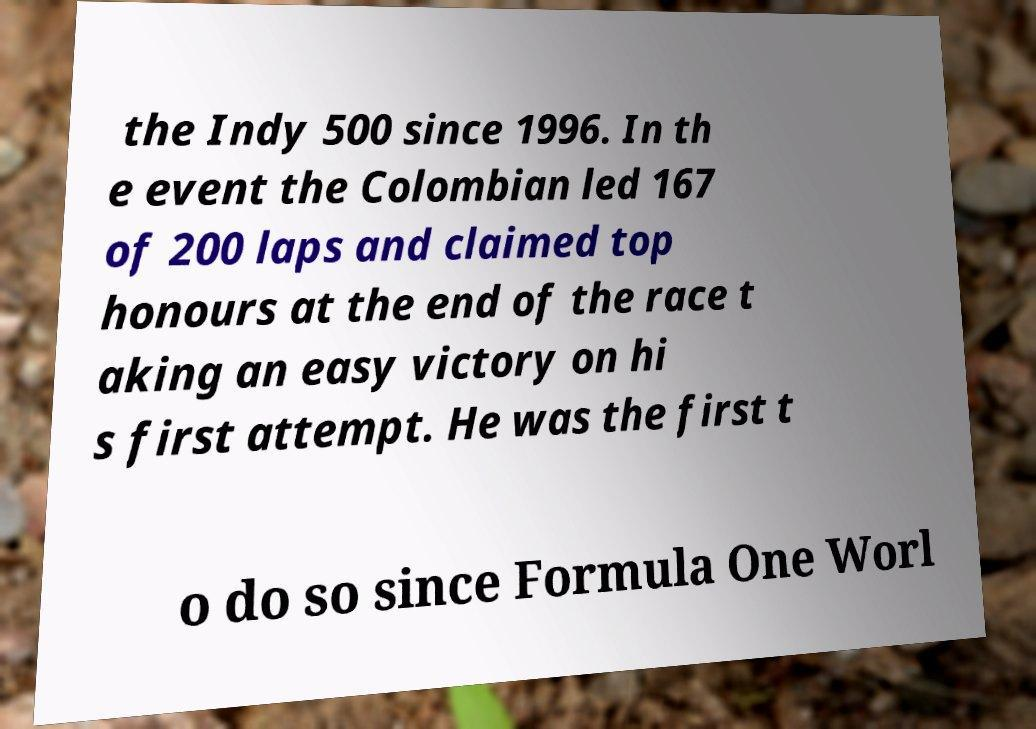Can you read and provide the text displayed in the image?This photo seems to have some interesting text. Can you extract and type it out for me? the Indy 500 since 1996. In th e event the Colombian led 167 of 200 laps and claimed top honours at the end of the race t aking an easy victory on hi s first attempt. He was the first t o do so since Formula One Worl 